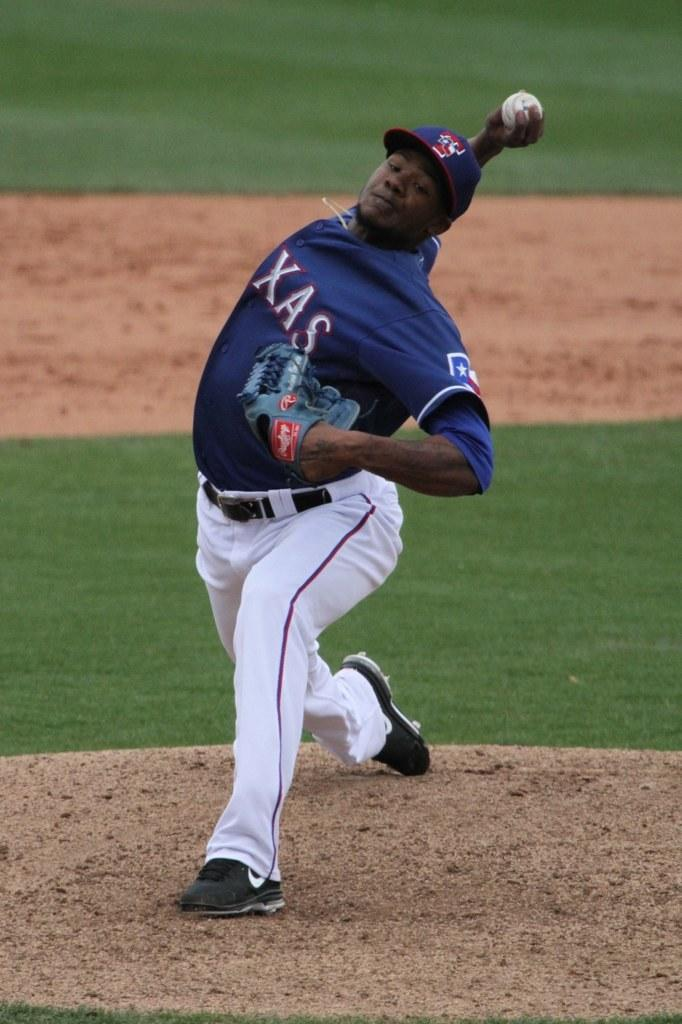<image>
Summarize the visual content of the image. A ballplayer in a TEXAS uniform pitches the ball. 